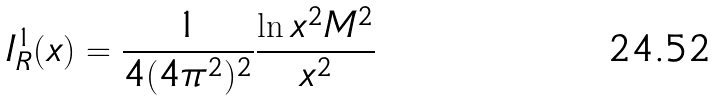Convert formula to latex. <formula><loc_0><loc_0><loc_500><loc_500>I ^ { 1 } _ { R } ( x ) = \frac { 1 } { 4 ( 4 \pi ^ { 2 } ) ^ { 2 } } \frac { \ln x ^ { 2 } M ^ { 2 } } { x ^ { 2 } }</formula> 